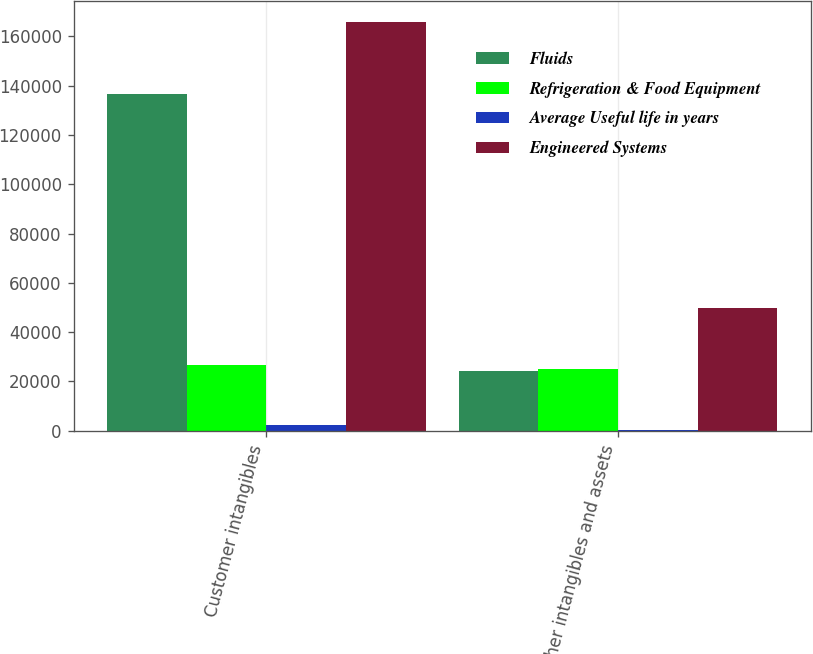<chart> <loc_0><loc_0><loc_500><loc_500><stacked_bar_chart><ecel><fcel>Customer intangibles<fcel>Other intangibles and assets<nl><fcel>Fluids<fcel>136495<fcel>24405<nl><fcel>Refrigeration & Food Equipment<fcel>26866<fcel>25000<nl><fcel>Average Useful life in years<fcel>2500<fcel>300<nl><fcel>Engineered Systems<fcel>165861<fcel>49705<nl></chart> 